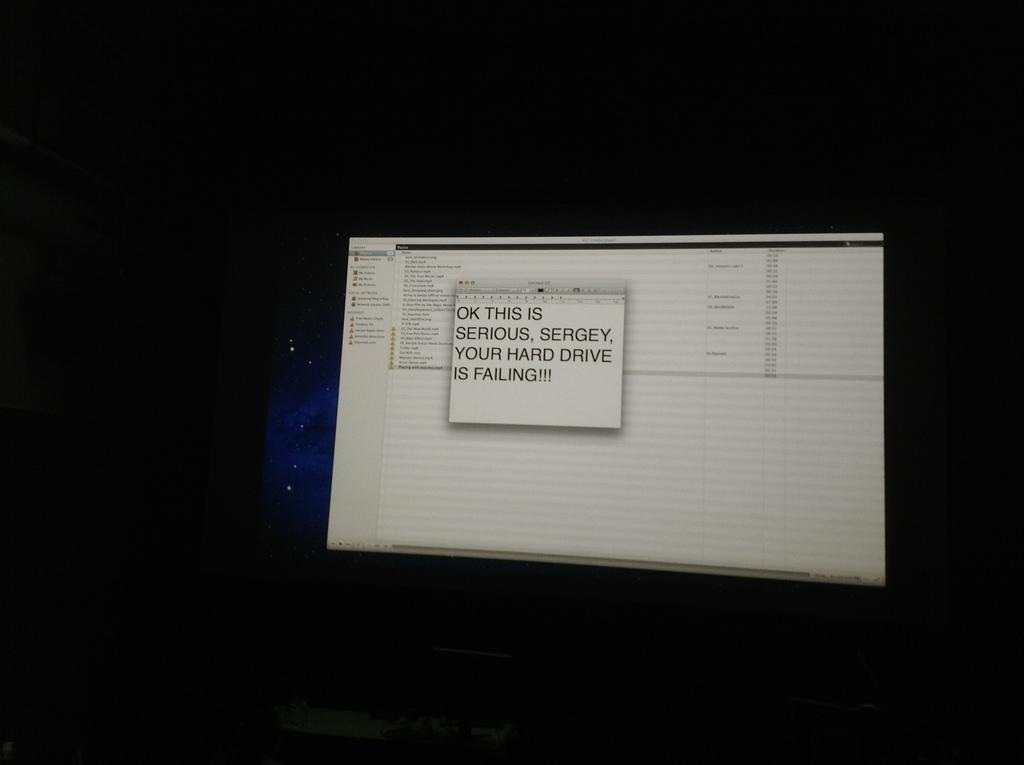<image>
Create a compact narrative representing the image presented. Computer screen that reads ok this is serious sergey, your hard drive is failing 